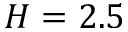Convert formula to latex. <formula><loc_0><loc_0><loc_500><loc_500>H = 2 . 5</formula> 